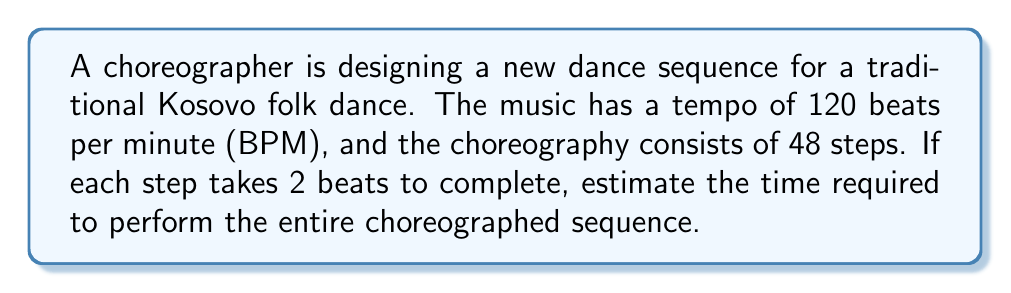Can you solve this math problem? To solve this problem, we need to follow these steps:

1. Calculate the duration of one beat:
   Since the tempo is 120 BPM, we can find the duration of one beat using:
   $$\text{Beat duration} = \frac{60 \text{ seconds}}{120 \text{ beats}} = 0.5 \text{ seconds per beat}$$

2. Determine the number of beats required for the entire sequence:
   Each step takes 2 beats, and there are 48 steps in total:
   $$\text{Total beats} = 48 \text{ steps} \times 2 \text{ beats per step} = 96 \text{ beats}$$

3. Calculate the total time for the sequence:
   Multiply the total number of beats by the duration of each beat:
   $$\text{Total time} = 96 \text{ beats} \times 0.5 \text{ seconds per beat} = 48 \text{ seconds}$$

Therefore, the estimated time required to perform the entire choreographed sequence is 48 seconds.
Answer: 48 seconds 